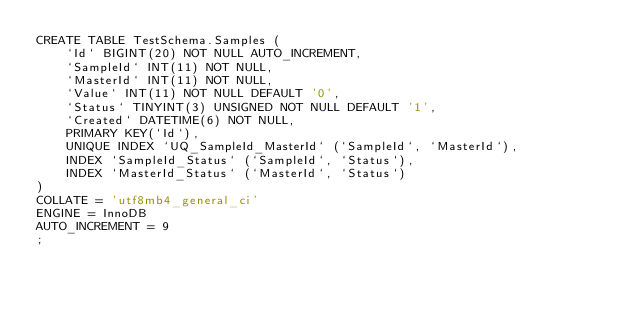<code> <loc_0><loc_0><loc_500><loc_500><_SQL_>CREATE TABLE TestSchema.Samples (
    `Id` BIGINT(20) NOT NULL AUTO_INCREMENT,
    `SampleId` INT(11) NOT NULL,
    `MasterId` INT(11) NOT NULL,
    `Value` INT(11) NOT NULL DEFAULT '0',
    `Status` TINYINT(3) UNSIGNED NOT NULL DEFAULT '1',
    `Created` DATETIME(6) NOT NULL,
    PRIMARY KEY(`Id`),
    UNIQUE INDEX `UQ_SampleId_MasterId` (`SampleId`, `MasterId`),
    INDEX `SampleId_Status` (`SampleId`, `Status`),
    INDEX `MasterId_Status` (`MasterId`, `Status`)
)
COLLATE = 'utf8mb4_general_ci'
ENGINE = InnoDB
AUTO_INCREMENT = 9
;</code> 